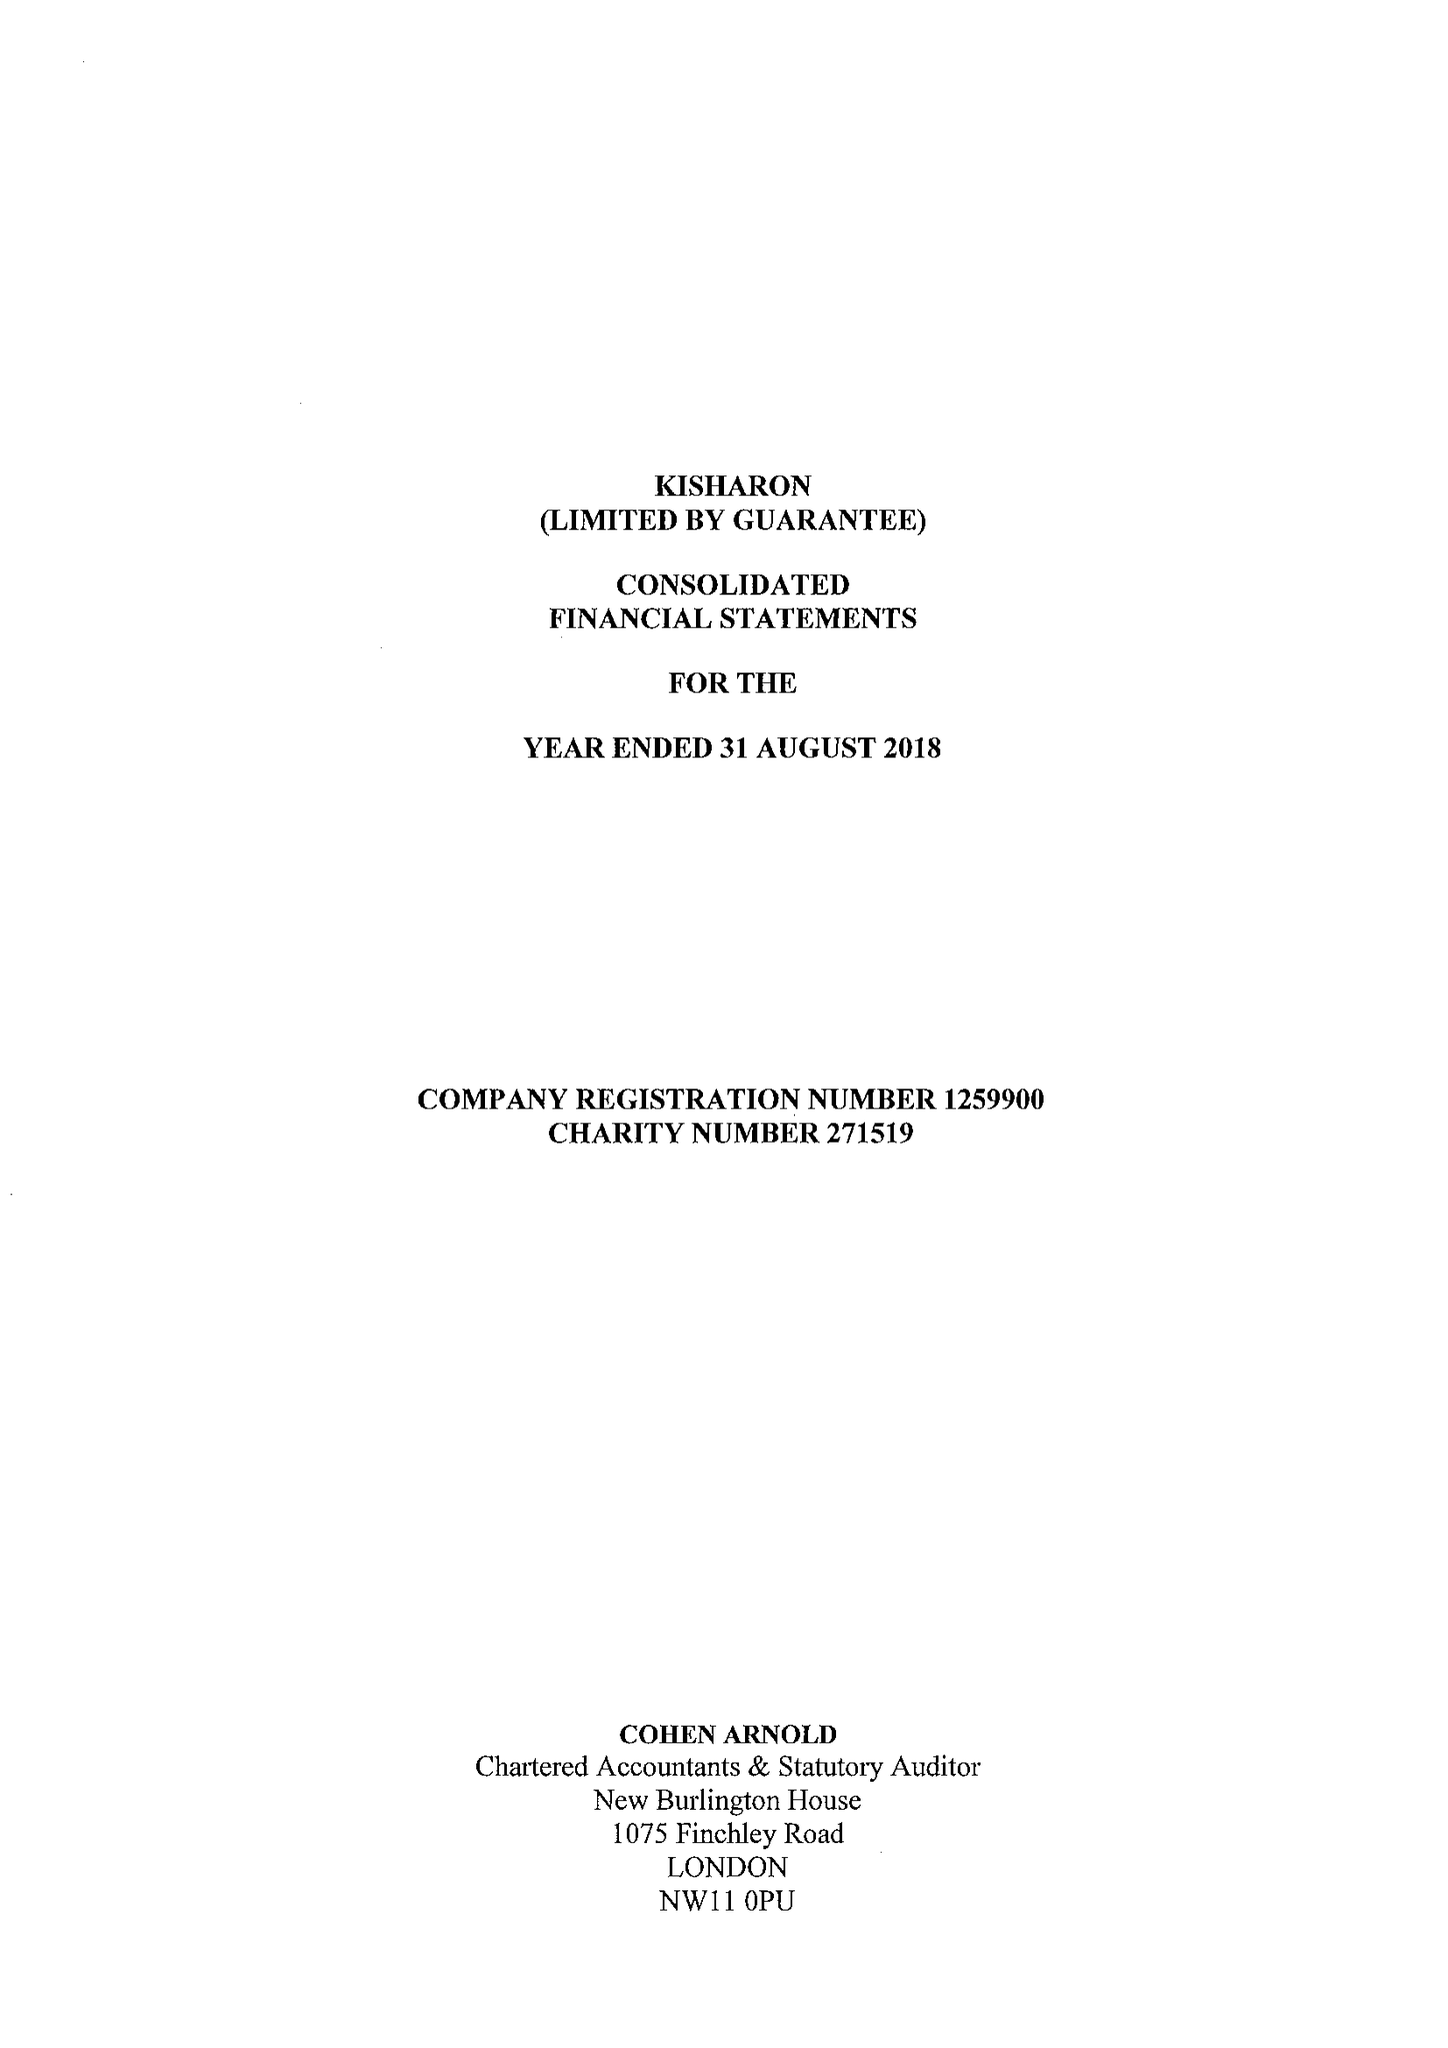What is the value for the charity_name?
Answer the question using a single word or phrase. Kisharon 